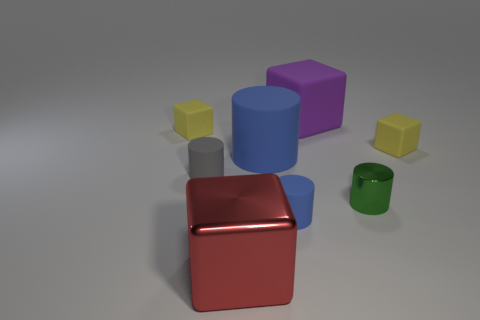Subtract all rubber cubes. How many cubes are left? 1 Subtract all yellow spheres. How many blue cylinders are left? 2 Subtract 2 cylinders. How many cylinders are left? 2 Add 1 big blue things. How many objects exist? 9 Subtract all gray cylinders. How many cylinders are left? 3 Subtract all red cubes. Subtract all red cylinders. How many cubes are left? 3 Add 2 metallic cylinders. How many metallic cylinders are left? 3 Add 5 large gray matte spheres. How many large gray matte spheres exist? 5 Subtract 0 green spheres. How many objects are left? 8 Subtract all tiny blue matte cylinders. Subtract all small blue things. How many objects are left? 6 